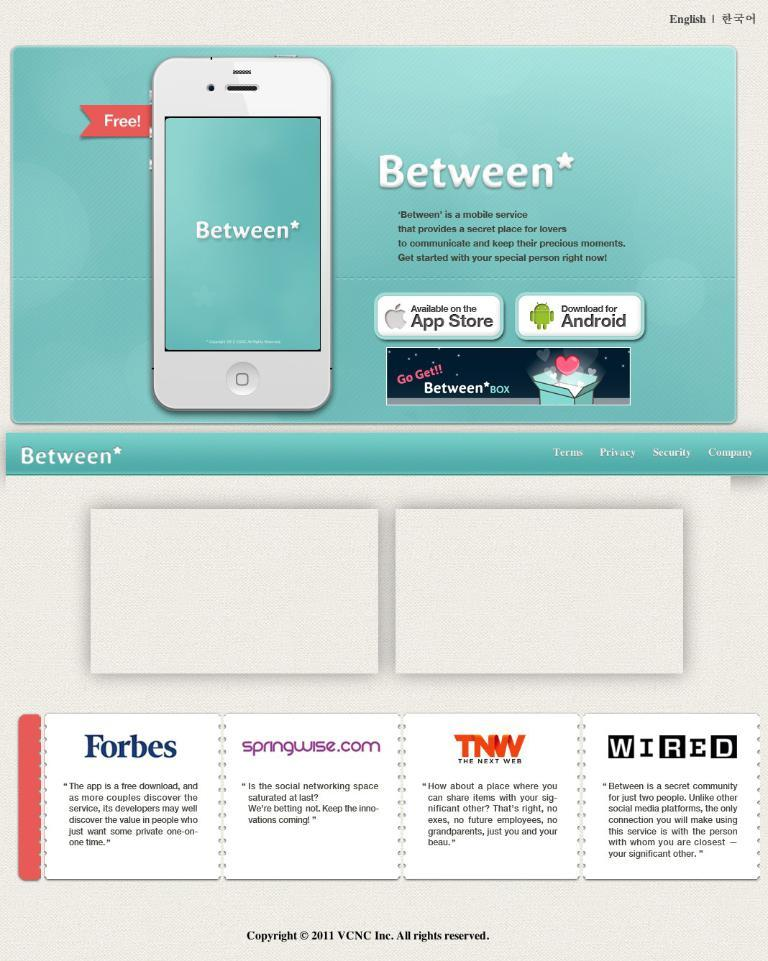<image>
Create a compact narrative representing the image presented. An advertisement for a mobile service called Between. 